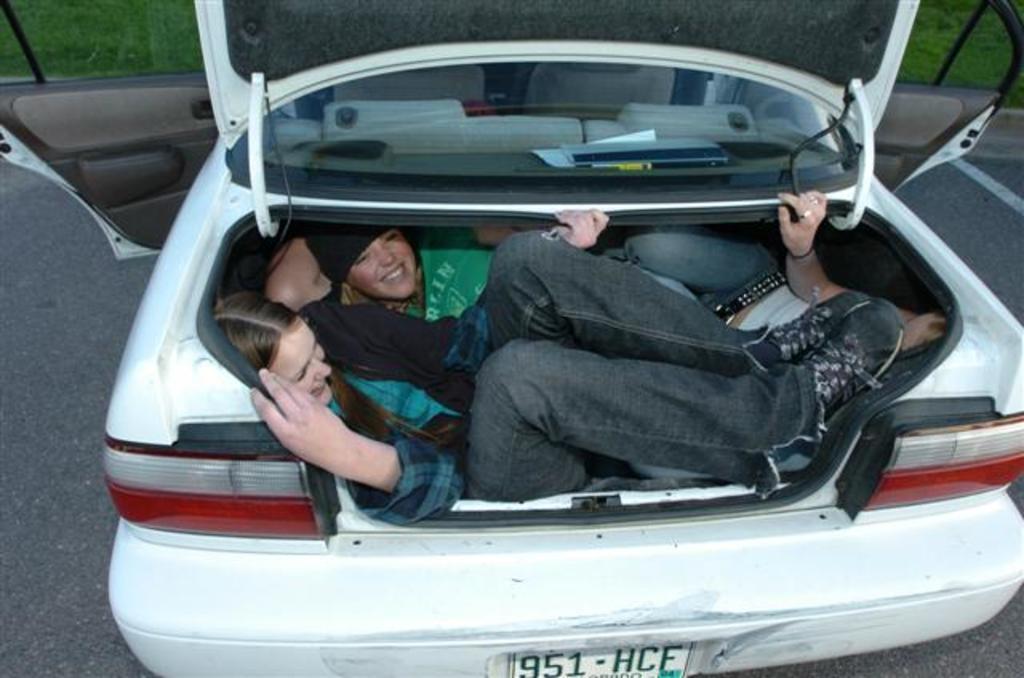Can you describe this image briefly? This is the picture taken in the outdoor, there are group of people lying on a car. The car is in white color. Background of the car is a grass. 